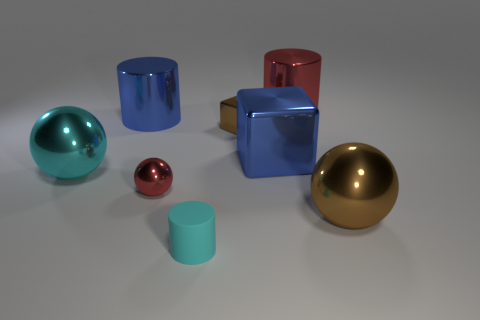Add 1 big yellow balls. How many objects exist? 9 Subtract all balls. How many objects are left? 5 Subtract 0 yellow cubes. How many objects are left? 8 Subtract all tiny cylinders. Subtract all big cyan metal balls. How many objects are left? 6 Add 4 brown objects. How many brown objects are left? 6 Add 1 tiny yellow metallic spheres. How many tiny yellow metallic spheres exist? 1 